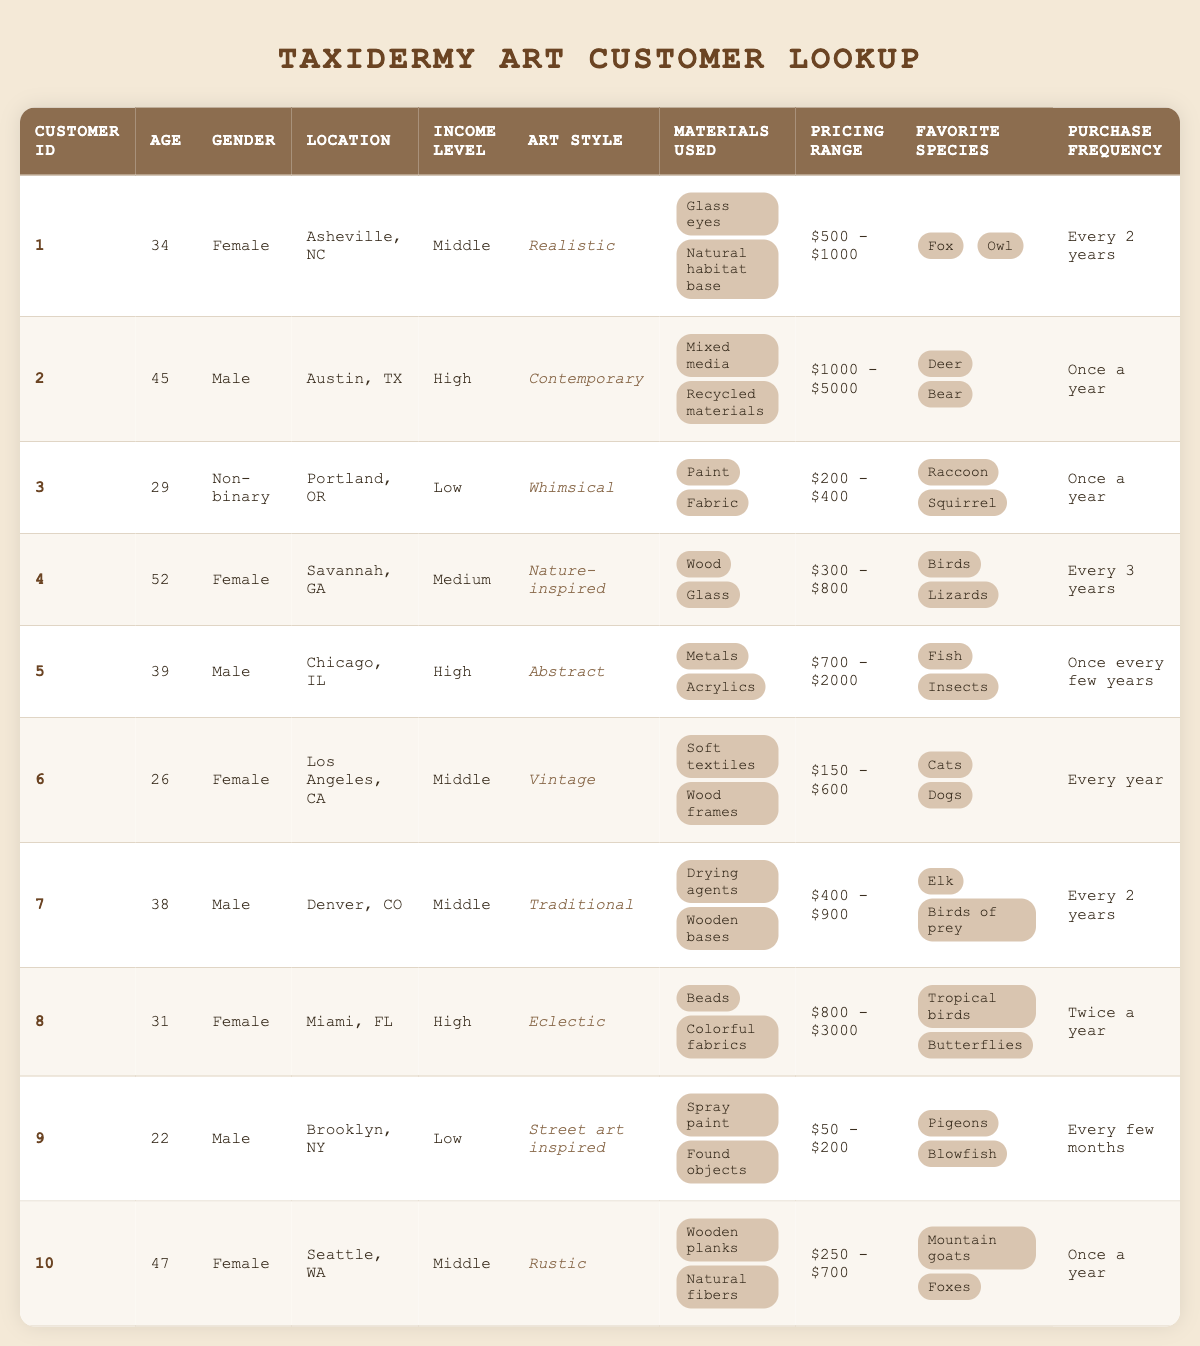What is the most common income level among the customers? By looking at the income levels in the table, we can see three categories: Low, Middle, and High. Counting the occurrences, we find: Low (3), Middle (4), High (3). The highest count is for the Middle income level.
Answer: Middle How many customers have a preference for "Eclectic" art style? In the table, we can see the art styles listed for each customer. By scanning the list, we find that there is only one customer (Customer ID 8) who prefers "Eclectic" art style.
Answer: 1 If a customer prefers "Whimsical" art style, how often do they purchase taxidermy art? Looking at Customer ID 3, which has the "Whimsical" art style preference, we see they purchase art "Once a year."
Answer: Once a year What is the median age of customers in the table? To find the median age, we first list all ages: 22, 26, 29, 31, 34, 38, 39, 45, 47, 52. Sorting these, we get 22, 26, 29, 31, 34, 38, 39, 45, 47, 52. There are 10 total ages, so the median will be the average of the 5th and 6th values: (34 + 38)/2 = 36.
Answer: 36 Is there any customer located in Chicago, IL, who has a preference for "Traditional" art style? Looking at the table, Customer ID 7 is located in Denver, CO with "Traditional" art style, while Customer ID 5 is in Chicago, IL but has a preference for "Abstract." Thus, there is no customer in Chicago, IL, who prefers "Traditional."
Answer: No Which species do customers with "High" income level prefer the most? The customers with a "High" income level include IDs 2, 5, and 8. Their favorite species are: Customer ID 2 - Deer and Bear, Customer ID 5 - Fish and Insects, and Customer ID 8 - Tropical birds and Butterflies. There is no single most preferred species since different customers prefer different species, but "Deer," "Bear," "Fish," "Insects," "Tropical birds," and "Butterflies" are represented.
Answer: No single preference What is the total number of unique favorite species among all customers? By compiling the list of favorite species, we have: Fox, Owl, Deer, Bear, Raccoon, Squirrel, Birds, Lizards, Fish, Insects, Cats, Dogs, Elk, Birds of prey, Tropical birds, Butterflies, Pigeons, Blowfish, Mountain goats, Foxes. We remove duplicates to find unique species: Fox, Owl, Deer, Bear, Raccoon, Squirrel, Birds, Lizards, Fish, Insects, Cats, Dogs, Elk, Birds of prey, Tropical birds, Butterflies, Pigeons, Blowfish, Mountain goats. That's a total of 18 unique species.
Answer: 18 Under what circumstances would a customer in Seattle, WA, make a purchase? Checking Customer ID 10 based in Seattle, WA, we see they have a "Rustic" art style preference and purchase "Once a year." Thus, the circumstances for their purchase would be annual.
Answer: Once a year 